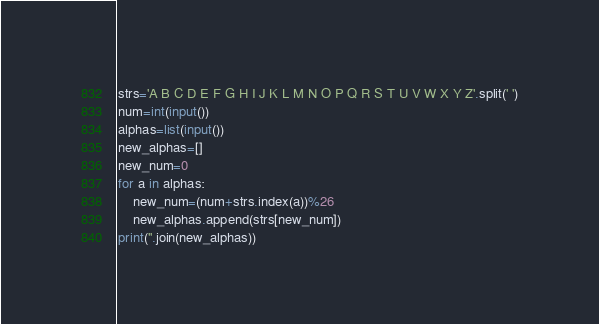Convert code to text. <code><loc_0><loc_0><loc_500><loc_500><_Python_>strs='A B C D E F G H I J K L M N O P Q R S T U V W X Y Z'.split(' ')
num=int(input())
alphas=list(input())
new_alphas=[]
new_num=0
for a in alphas:
    new_num=(num+strs.index(a))%26 
    new_alphas.append(strs[new_num])
print(''.join(new_alphas))</code> 